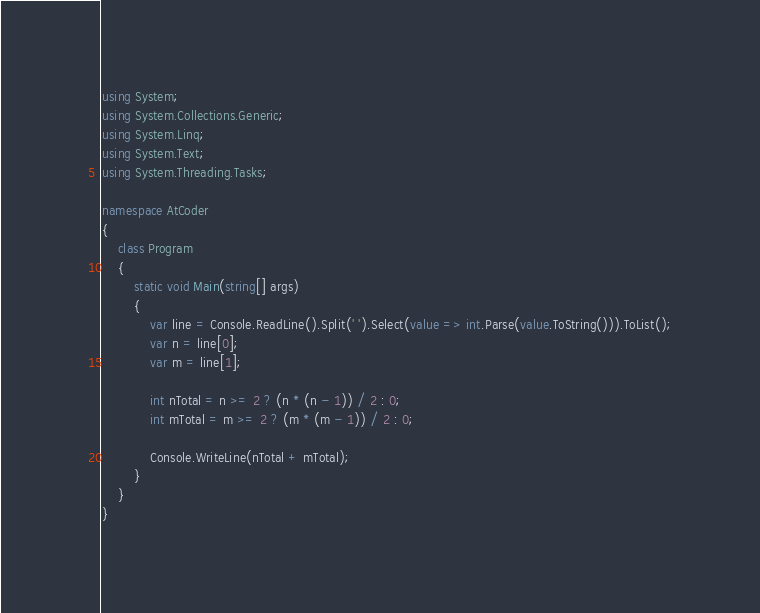<code> <loc_0><loc_0><loc_500><loc_500><_C#_>using System;
using System.Collections.Generic;
using System.Linq;
using System.Text;
using System.Threading.Tasks;

namespace AtCoder
{
	class Program
	{
		static void Main(string[] args)
		{
			var line = Console.ReadLine().Split(' ').Select(value => int.Parse(value.ToString())).ToList();
			var n = line[0];
			var m = line[1];

			int nTotal = n >= 2 ? (n * (n - 1)) / 2 : 0;
			int mTotal = m >= 2 ? (m * (m - 1)) / 2 : 0;
			
			Console.WriteLine(nTotal + mTotal);
		}
	}
}
</code> 